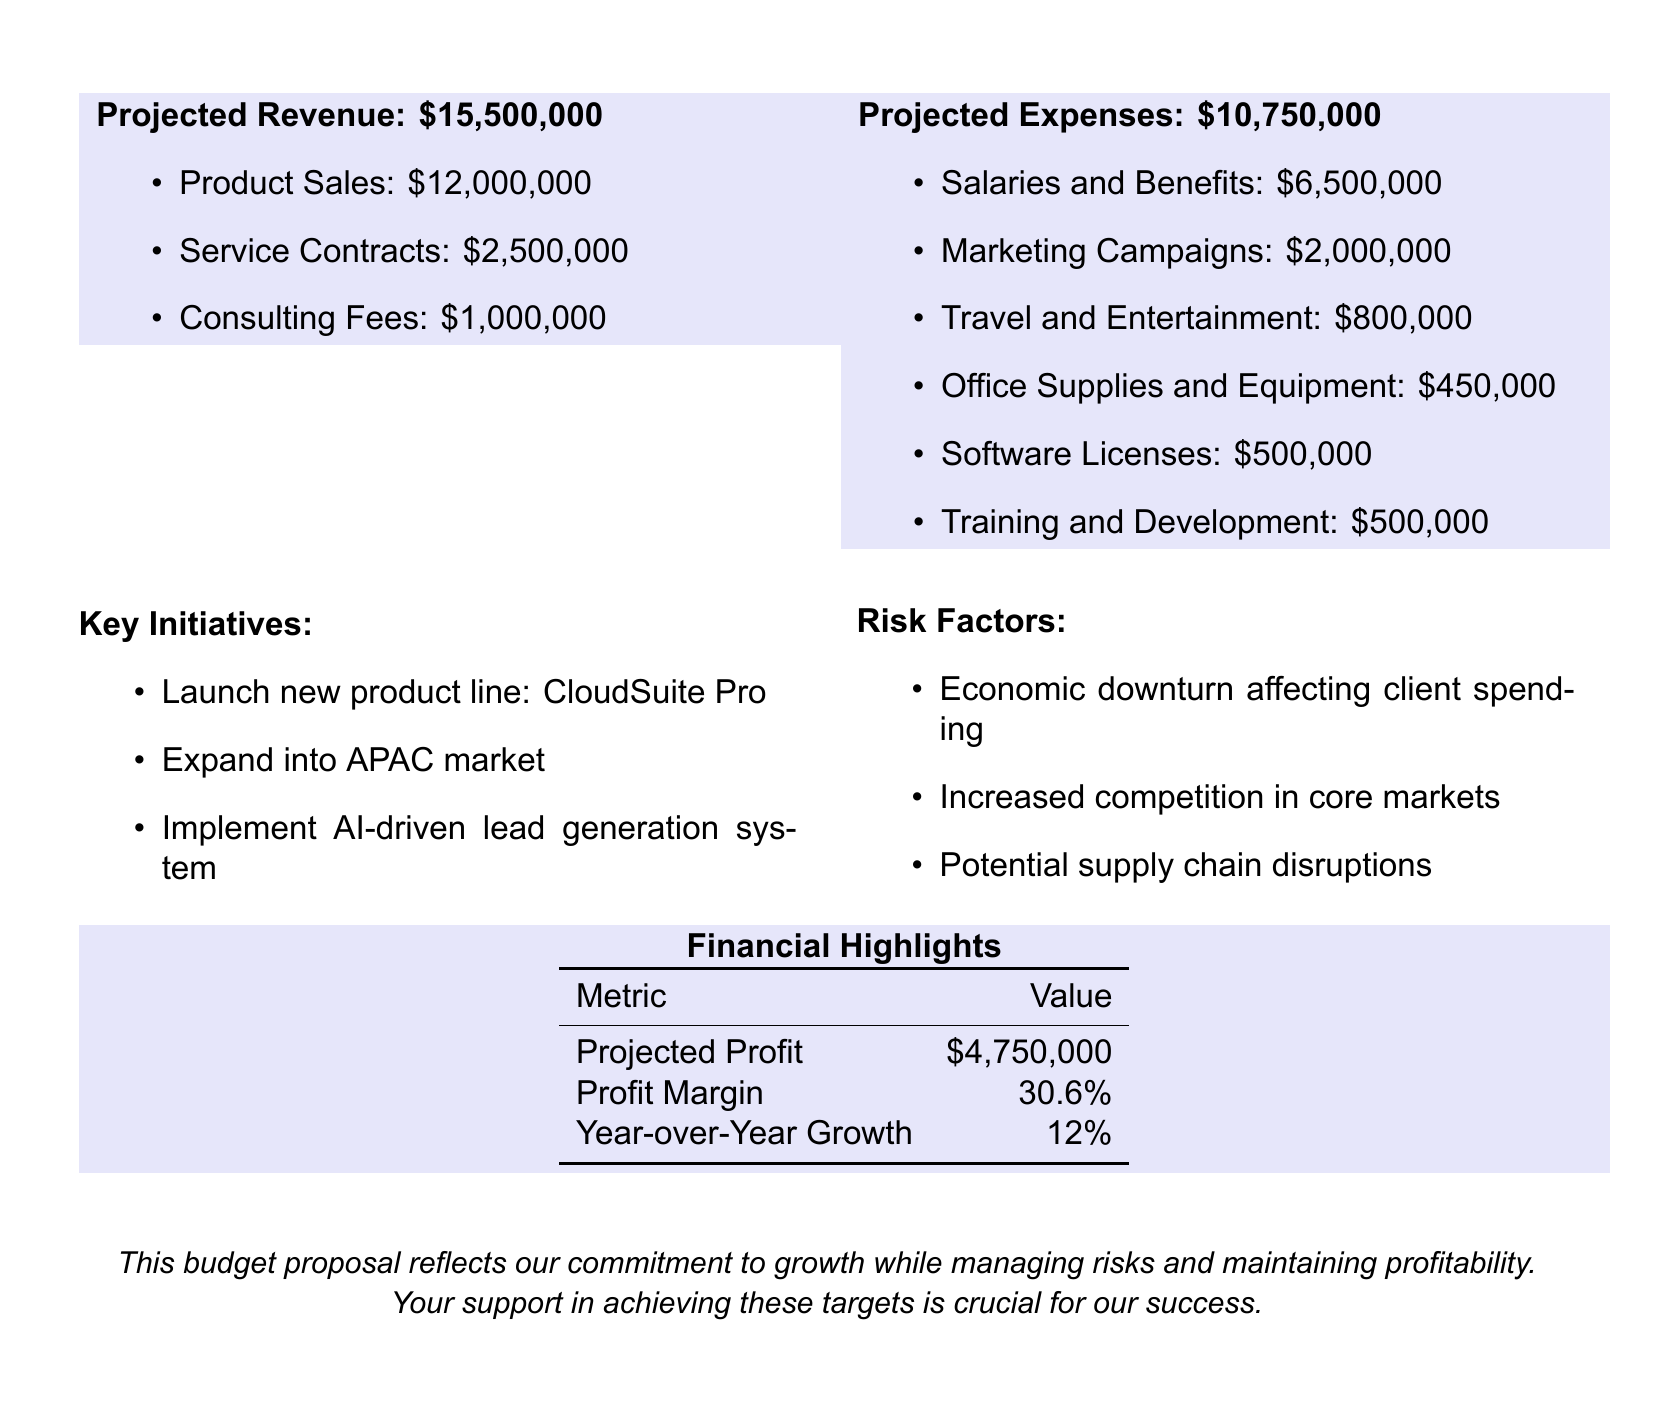What is the projected revenue? The projected revenue is explicitly stated in the document, which totals $15,500,000.
Answer: $15,500,000 What are the projected expenses? The total projected expenses are mentioned clearly in the document, which is $10,750,000.
Answer: $10,750,000 What is the projected profit? The projected profit can be calculated from the difference between projected revenue and expenses, which is $4,750,000.
Answer: $4,750,000 What percentage is the profit margin? The document specifies the profit margin as a percentage, which is 30.6%.
Answer: 30.6% What is one key initiative mentioned? The document lists key initiatives for the department, one of which is launching the new product line, CloudSuite Pro.
Answer: CloudSuite Pro What is the year-over-year growth? The document provides the year-over-year growth metric, which is 12%.
Answer: 12% What is one risk factor listed? The document outlines several risk factors, one of which is the economic downturn affecting client spending.
Answer: Economic downturn How much is allocated for marketing campaigns? The expense breakdown shows that $2,000,000 is allocated for marketing campaigns.
Answer: $2,000,000 Which market does the department plan to expand into? The document mentions plans to expand into the APAC market.
Answer: APAC market 